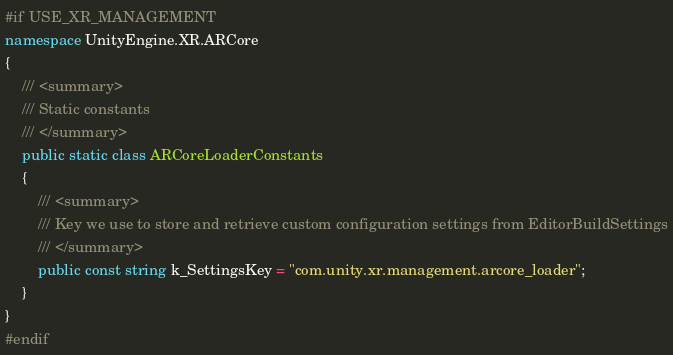Convert code to text. <code><loc_0><loc_0><loc_500><loc_500><_C#_>#if USE_XR_MANAGEMENT
namespace UnityEngine.XR.ARCore
{
    /// <summary>
    /// Static constants
    /// </summary>
    public static class ARCoreLoaderConstants
    {
        /// <summary>
        /// Key we use to store and retrieve custom configuration settings from EditorBuildSettings
        /// </summary>
        public const string k_SettingsKey = "com.unity.xr.management.arcore_loader";
    }
}
#endif</code> 